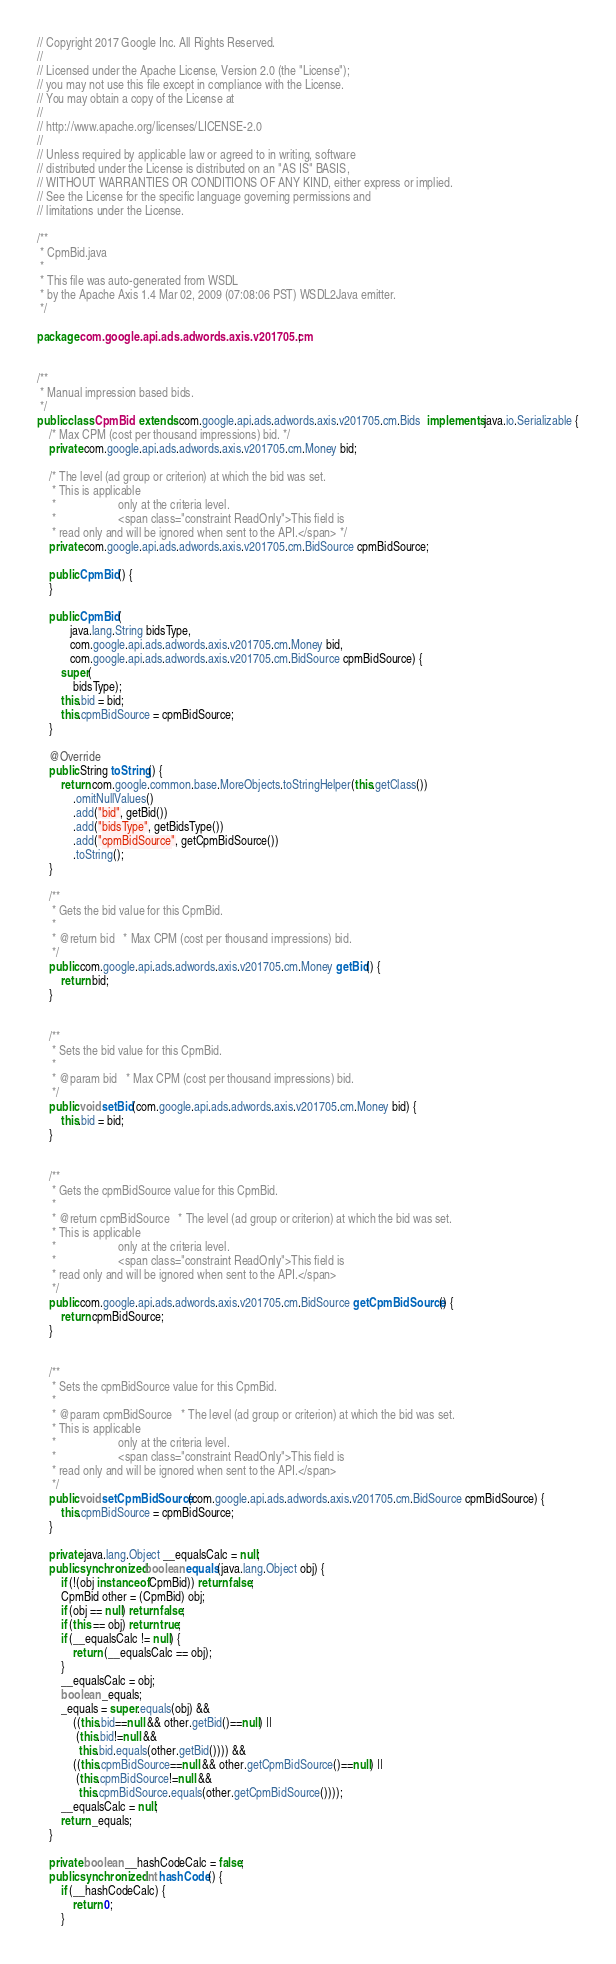<code> <loc_0><loc_0><loc_500><loc_500><_Java_>// Copyright 2017 Google Inc. All Rights Reserved.
//
// Licensed under the Apache License, Version 2.0 (the "License");
// you may not use this file except in compliance with the License.
// You may obtain a copy of the License at
//
// http://www.apache.org/licenses/LICENSE-2.0
//
// Unless required by applicable law or agreed to in writing, software
// distributed under the License is distributed on an "AS IS" BASIS,
// WITHOUT WARRANTIES OR CONDITIONS OF ANY KIND, either express or implied.
// See the License for the specific language governing permissions and
// limitations under the License.

/**
 * CpmBid.java
 *
 * This file was auto-generated from WSDL
 * by the Apache Axis 1.4 Mar 02, 2009 (07:08:06 PST) WSDL2Java emitter.
 */

package com.google.api.ads.adwords.axis.v201705.cm;


/**
 * Manual impression based bids.
 */
public class CpmBid  extends com.google.api.ads.adwords.axis.v201705.cm.Bids  implements java.io.Serializable {
    /* Max CPM (cost per thousand impressions) bid. */
    private com.google.api.ads.adwords.axis.v201705.cm.Money bid;

    /* The level (ad group or criterion) at which the bid was set.
     * This is applicable
     *                     only at the criteria level.
     *                     <span class="constraint ReadOnly">This field is
     * read only and will be ignored when sent to the API.</span> */
    private com.google.api.ads.adwords.axis.v201705.cm.BidSource cpmBidSource;

    public CpmBid() {
    }

    public CpmBid(
           java.lang.String bidsType,
           com.google.api.ads.adwords.axis.v201705.cm.Money bid,
           com.google.api.ads.adwords.axis.v201705.cm.BidSource cpmBidSource) {
        super(
            bidsType);
        this.bid = bid;
        this.cpmBidSource = cpmBidSource;
    }

    @Override
    public String toString() {
        return com.google.common.base.MoreObjects.toStringHelper(this.getClass())
            .omitNullValues()
            .add("bid", getBid())
            .add("bidsType", getBidsType())
            .add("cpmBidSource", getCpmBidSource())
            .toString();
    }

    /**
     * Gets the bid value for this CpmBid.
     * 
     * @return bid   * Max CPM (cost per thousand impressions) bid.
     */
    public com.google.api.ads.adwords.axis.v201705.cm.Money getBid() {
        return bid;
    }


    /**
     * Sets the bid value for this CpmBid.
     * 
     * @param bid   * Max CPM (cost per thousand impressions) bid.
     */
    public void setBid(com.google.api.ads.adwords.axis.v201705.cm.Money bid) {
        this.bid = bid;
    }


    /**
     * Gets the cpmBidSource value for this CpmBid.
     * 
     * @return cpmBidSource   * The level (ad group or criterion) at which the bid was set.
     * This is applicable
     *                     only at the criteria level.
     *                     <span class="constraint ReadOnly">This field is
     * read only and will be ignored when sent to the API.</span>
     */
    public com.google.api.ads.adwords.axis.v201705.cm.BidSource getCpmBidSource() {
        return cpmBidSource;
    }


    /**
     * Sets the cpmBidSource value for this CpmBid.
     * 
     * @param cpmBidSource   * The level (ad group or criterion) at which the bid was set.
     * This is applicable
     *                     only at the criteria level.
     *                     <span class="constraint ReadOnly">This field is
     * read only and will be ignored when sent to the API.</span>
     */
    public void setCpmBidSource(com.google.api.ads.adwords.axis.v201705.cm.BidSource cpmBidSource) {
        this.cpmBidSource = cpmBidSource;
    }

    private java.lang.Object __equalsCalc = null;
    public synchronized boolean equals(java.lang.Object obj) {
        if (!(obj instanceof CpmBid)) return false;
        CpmBid other = (CpmBid) obj;
        if (obj == null) return false;
        if (this == obj) return true;
        if (__equalsCalc != null) {
            return (__equalsCalc == obj);
        }
        __equalsCalc = obj;
        boolean _equals;
        _equals = super.equals(obj) && 
            ((this.bid==null && other.getBid()==null) || 
             (this.bid!=null &&
              this.bid.equals(other.getBid()))) &&
            ((this.cpmBidSource==null && other.getCpmBidSource()==null) || 
             (this.cpmBidSource!=null &&
              this.cpmBidSource.equals(other.getCpmBidSource())));
        __equalsCalc = null;
        return _equals;
    }

    private boolean __hashCodeCalc = false;
    public synchronized int hashCode() {
        if (__hashCodeCalc) {
            return 0;
        }</code> 